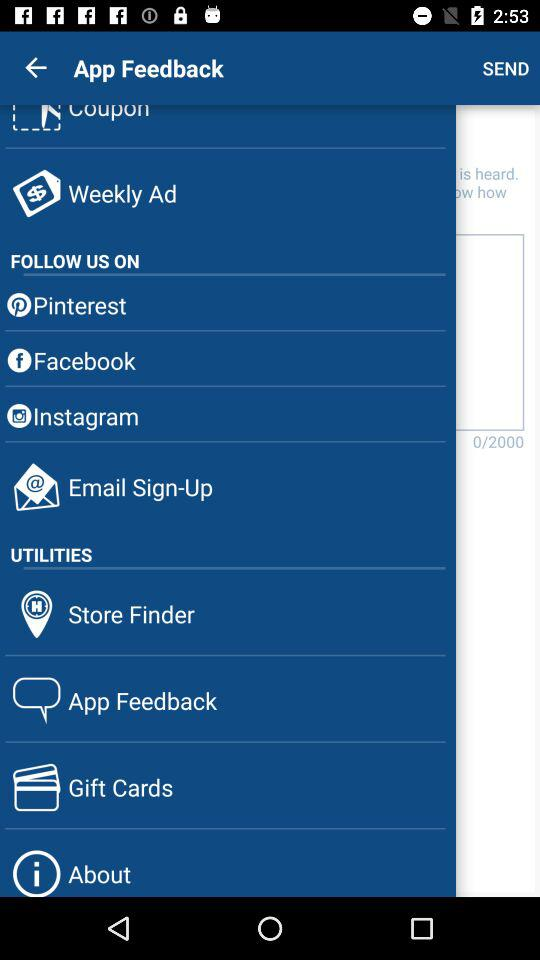How many items are there in total?
Answer the question using a single word or phrase. 10 